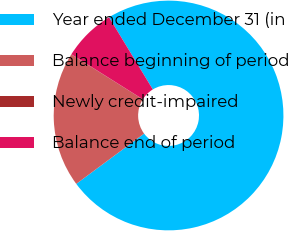<chart> <loc_0><loc_0><loc_500><loc_500><pie_chart><fcel>Year ended December 31 (in<fcel>Balance beginning of period<fcel>Newly credit-impaired<fcel>Balance end of period<nl><fcel>73.52%<fcel>19.06%<fcel>0.04%<fcel>7.38%<nl></chart> 